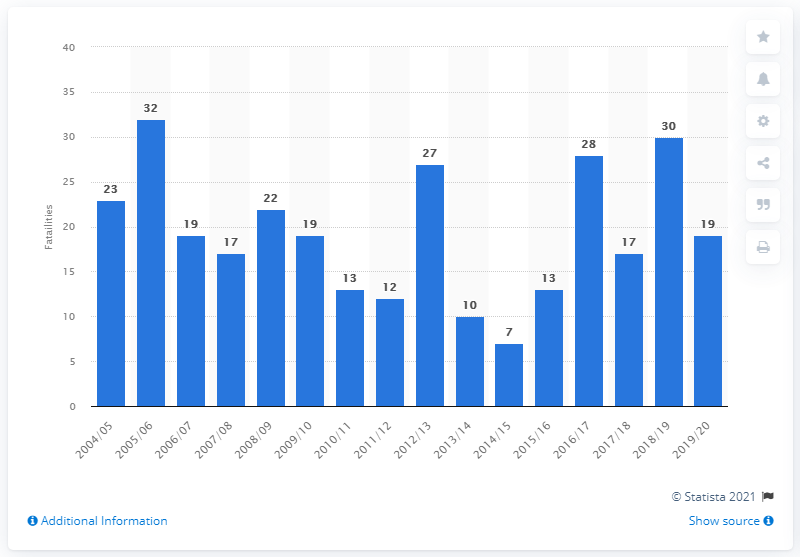Outline some significant characteristics in this image. In the year 2005/2006, a record number of 32 people lost their lives as a result of police pursuits. 